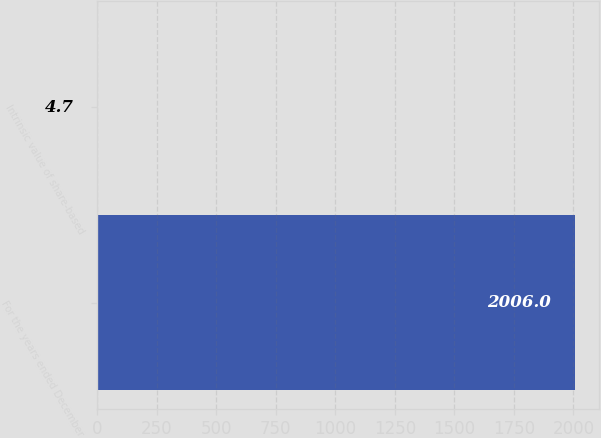<chart> <loc_0><loc_0><loc_500><loc_500><bar_chart><fcel>For the years ended December<fcel>Intrinsic value of share-based<nl><fcel>2006<fcel>4.7<nl></chart> 